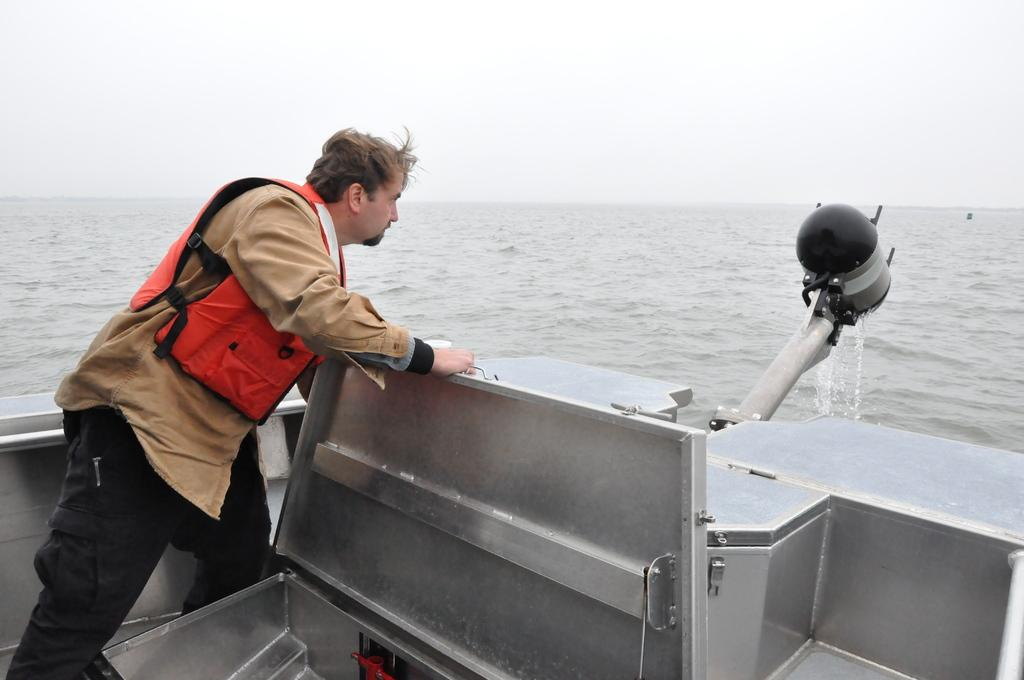What is the main subject of the image? The main subject of the image is a boat. What is the boat doing in the image? The boat is moving on the water in the image. Is there anyone on the boat? Yes, there is a person standing in the boat. What is the person doing on the boat? The person is repairing something. What type of activity is the person blowing in the image? There is no indication in the image that the person is blowing or participating in any activity involving blowing. 